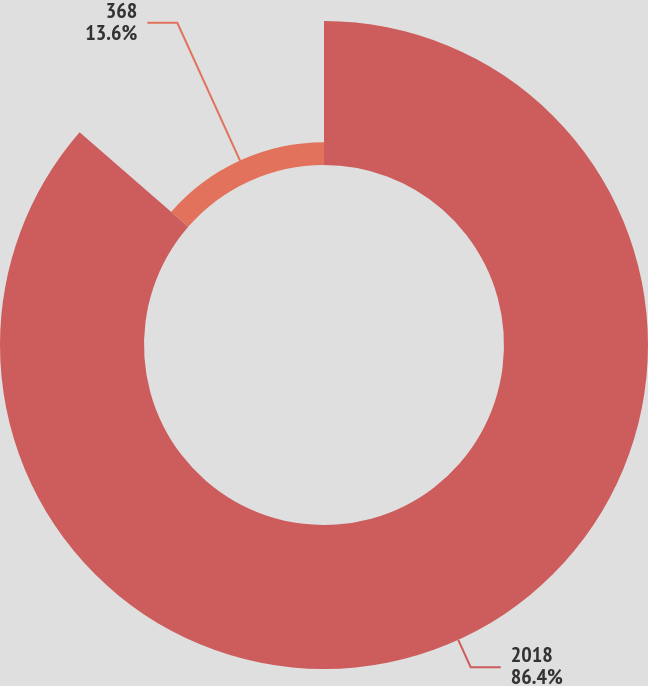Convert chart to OTSL. <chart><loc_0><loc_0><loc_500><loc_500><pie_chart><fcel>2018<fcel>368<nl><fcel>86.4%<fcel>13.6%<nl></chart> 